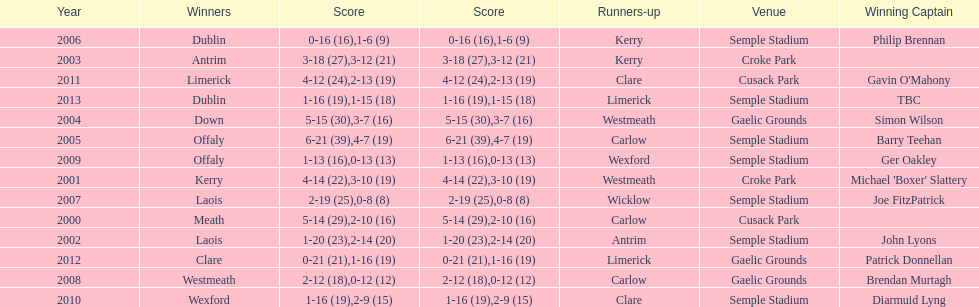Who scored the least? Wicklow. 